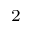<formula> <loc_0><loc_0><loc_500><loc_500>_ { 2 }</formula> 